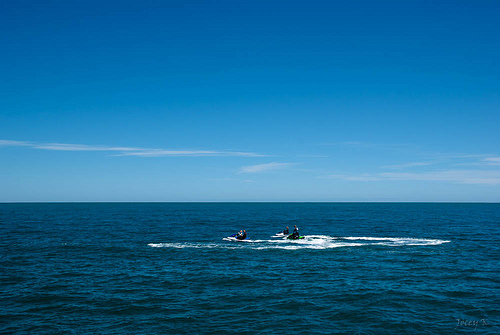<image>
Is the water under the sky? Yes. The water is positioned underneath the sky, with the sky above it in the vertical space. Where is the person in relation to the sea? Is it next to the sea? Yes. The person is positioned adjacent to the sea, located nearby in the same general area. 